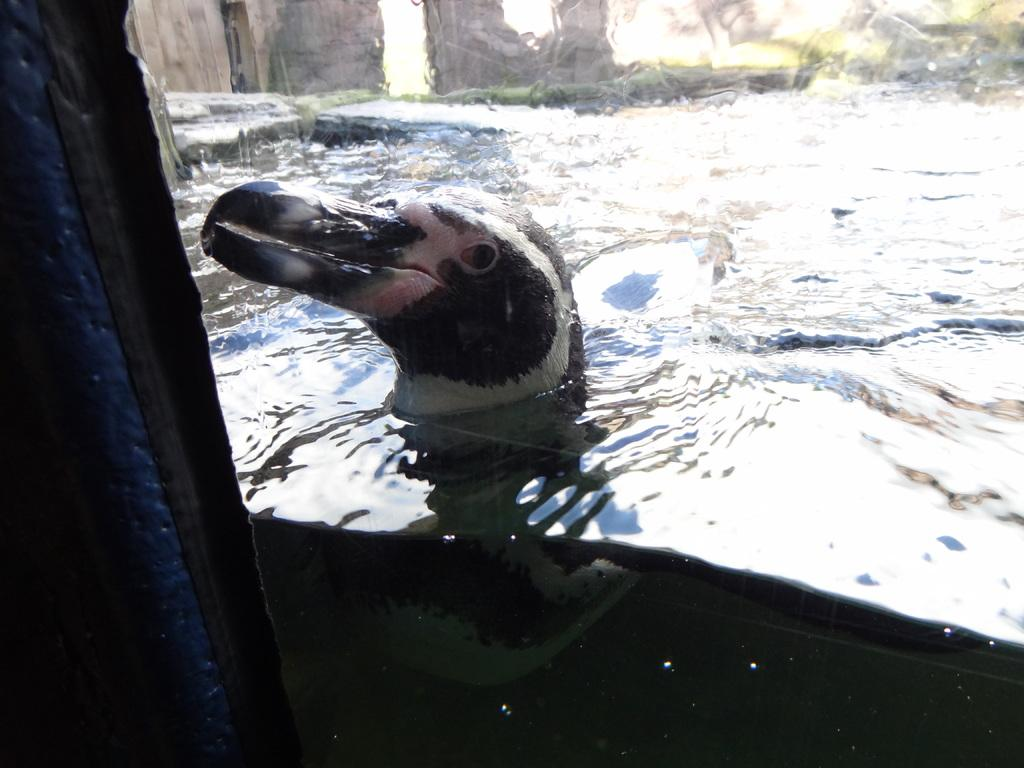What type of animal is in the water in the image? There is a duck in the water in the image. What is located behind the duck? The duck is behind a mirror. What type of vegetation can be seen in the image? There are trees visible in the image. What is the primary element visible in the image? There is water visible in the image. What type of leather is visible on the duck in the image? There is no leather visible on the duck in the image; it is a real duck in the water. How many visitors are present in the image? There are no visitors present in the image; it only features a duck in the water behind a mirror, trees, and water. 